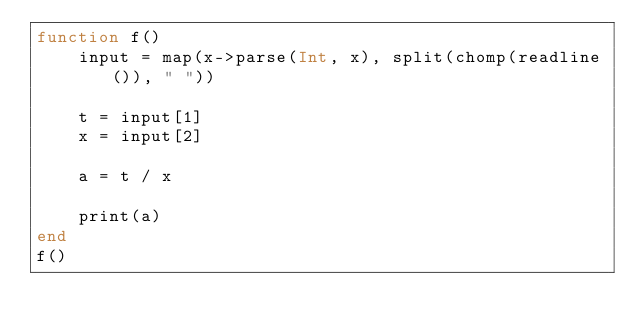Convert code to text. <code><loc_0><loc_0><loc_500><loc_500><_Julia_>function f()
    input = map(x->parse(Int, x), split(chomp(readline()), " "))

    t = input[1]
    x = input[2]

    a = t / x

    print(a)
end
f()</code> 